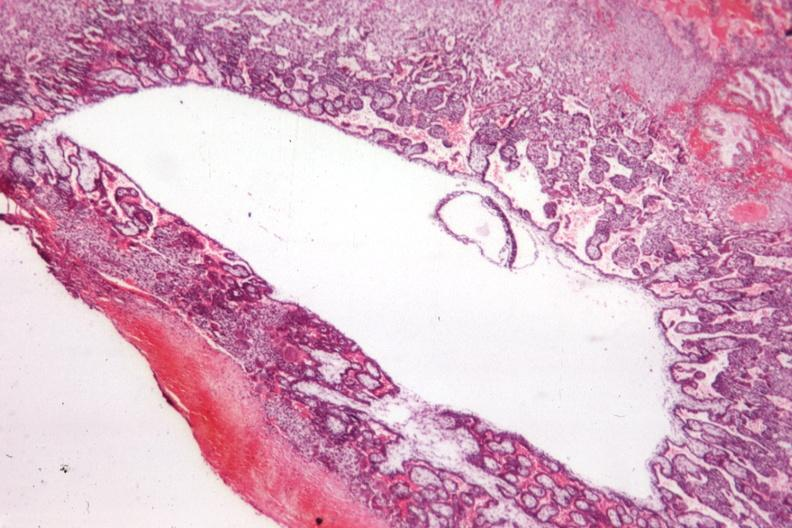what is present?
Answer the question using a single word or phrase. Uterus 